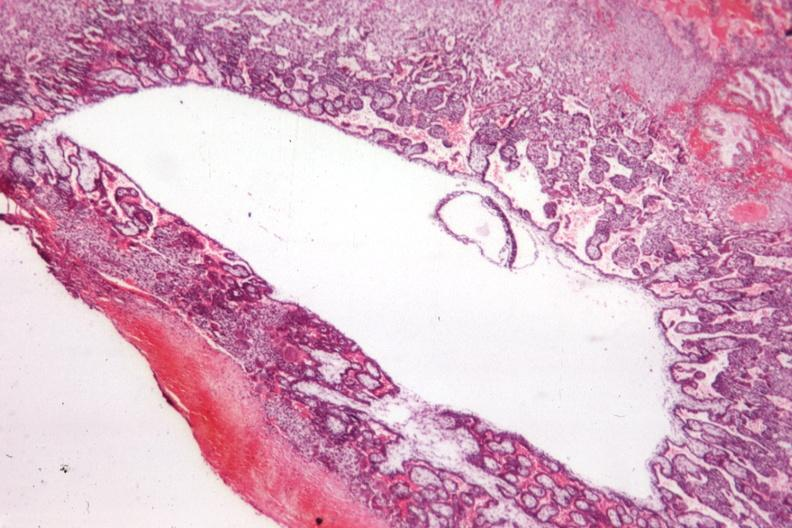what is present?
Answer the question using a single word or phrase. Uterus 